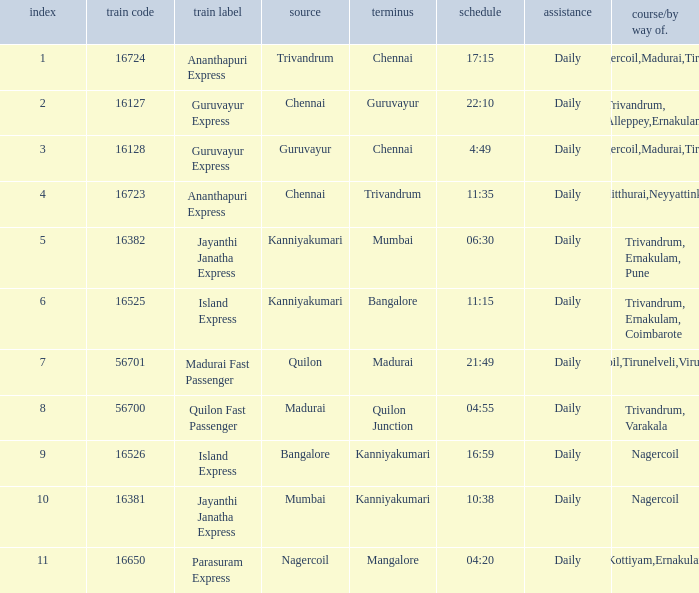What is the route/via when the destination is listed as Madurai? Nagercoil,Tirunelveli,Virudunagar. Can you give me this table as a dict? {'header': ['index', 'train code', 'train label', 'source', 'terminus', 'schedule', 'assistance', 'course/by way of.'], 'rows': [['1', '16724', 'Ananthapuri Express', 'Trivandrum', 'Chennai', '17:15', 'Daily', 'Nagercoil,Madurai,Tiruchi'], ['2', '16127', 'Guruvayur Express', 'Chennai', 'Guruvayur', '22:10', 'Daily', 'Trivandrum, Alleppey,Ernakulam'], ['3', '16128', 'Guruvayur Express', 'Guruvayur', 'Chennai', '4:49', 'Daily', 'Nagercoil,Madurai,Tiruchi'], ['4', '16723', 'Ananthapuri Express', 'Chennai', 'Trivandrum', '11:35', 'Daily', 'Kulitthurai,Neyyattinkara'], ['5', '16382', 'Jayanthi Janatha Express', 'Kanniyakumari', 'Mumbai', '06:30', 'Daily', 'Trivandrum, Ernakulam, Pune'], ['6', '16525', 'Island Express', 'Kanniyakumari', 'Bangalore', '11:15', 'Daily', 'Trivandrum, Ernakulam, Coimbarote'], ['7', '56701', 'Madurai Fast Passenger', 'Quilon', 'Madurai', '21:49', 'Daily', 'Nagercoil,Tirunelveli,Virudunagar'], ['8', '56700', 'Quilon Fast Passenger', 'Madurai', 'Quilon Junction', '04:55', 'Daily', 'Trivandrum, Varakala'], ['9', '16526', 'Island Express', 'Bangalore', 'Kanniyakumari', '16:59', 'Daily', 'Nagercoil'], ['10', '16381', 'Jayanthi Janatha Express', 'Mumbai', 'Kanniyakumari', '10:38', 'Daily', 'Nagercoil'], ['11', '16650', 'Parasuram Express', 'Nagercoil', 'Mangalore', '04:20', 'Daily', 'Trivandrum,Kottiyam,Ernakulam,Kozhikode']]} 